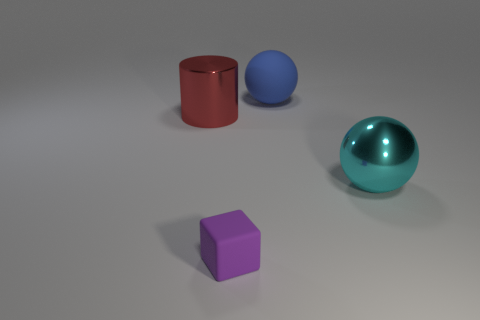Does the large rubber object have the same color as the cylinder?
Keep it short and to the point. No. Is there any other thing that is the same color as the rubber cube?
Make the answer very short. No. There is a large shiny thing in front of the red object; does it have the same shape as the metallic object left of the rubber ball?
Your response must be concise. No. How many objects are either small red cylinders or big things that are to the left of the large cyan thing?
Give a very brief answer. 2. What number of other things are there of the same size as the blue sphere?
Ensure brevity in your answer.  2. Do the large object that is left of the small purple rubber cube and the large sphere in front of the blue ball have the same material?
Give a very brief answer. Yes. What number of cyan objects are on the right side of the large blue rubber ball?
Your response must be concise. 1. What number of brown objects are large cylinders or big spheres?
Offer a terse response. 0. There is another cyan sphere that is the same size as the matte ball; what is its material?
Ensure brevity in your answer.  Metal. What shape is the large object that is in front of the big blue rubber ball and behind the cyan ball?
Give a very brief answer. Cylinder. 